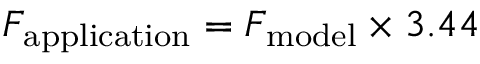Convert formula to latex. <formula><loc_0><loc_0><loc_500><loc_500>F _ { a p p l i c a t i o n } = F _ { m o d e l } \times 3 . 4 4</formula> 